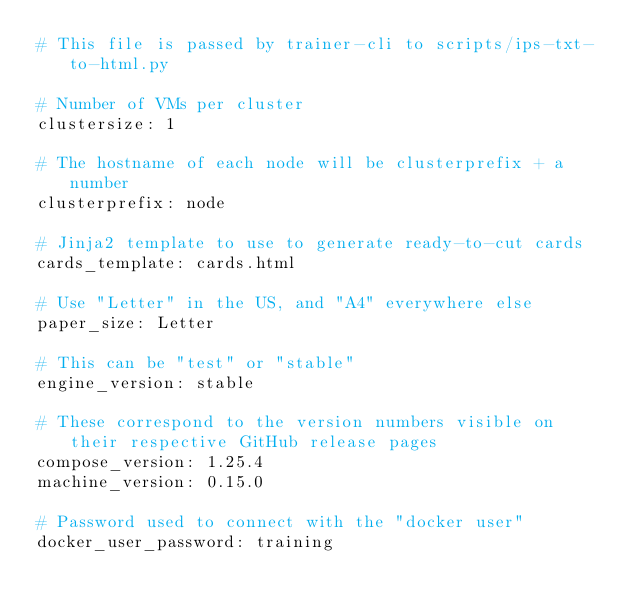<code> <loc_0><loc_0><loc_500><loc_500><_YAML_># This file is passed by trainer-cli to scripts/ips-txt-to-html.py

# Number of VMs per cluster
clustersize: 1

# The hostname of each node will be clusterprefix + a number
clusterprefix: node

# Jinja2 template to use to generate ready-to-cut cards
cards_template: cards.html

# Use "Letter" in the US, and "A4" everywhere else
paper_size: Letter

# This can be "test" or "stable"
engine_version: stable

# These correspond to the version numbers visible on their respective GitHub release pages
compose_version: 1.25.4
machine_version: 0.15.0

# Password used to connect with the "docker user"
docker_user_password: training
</code> 